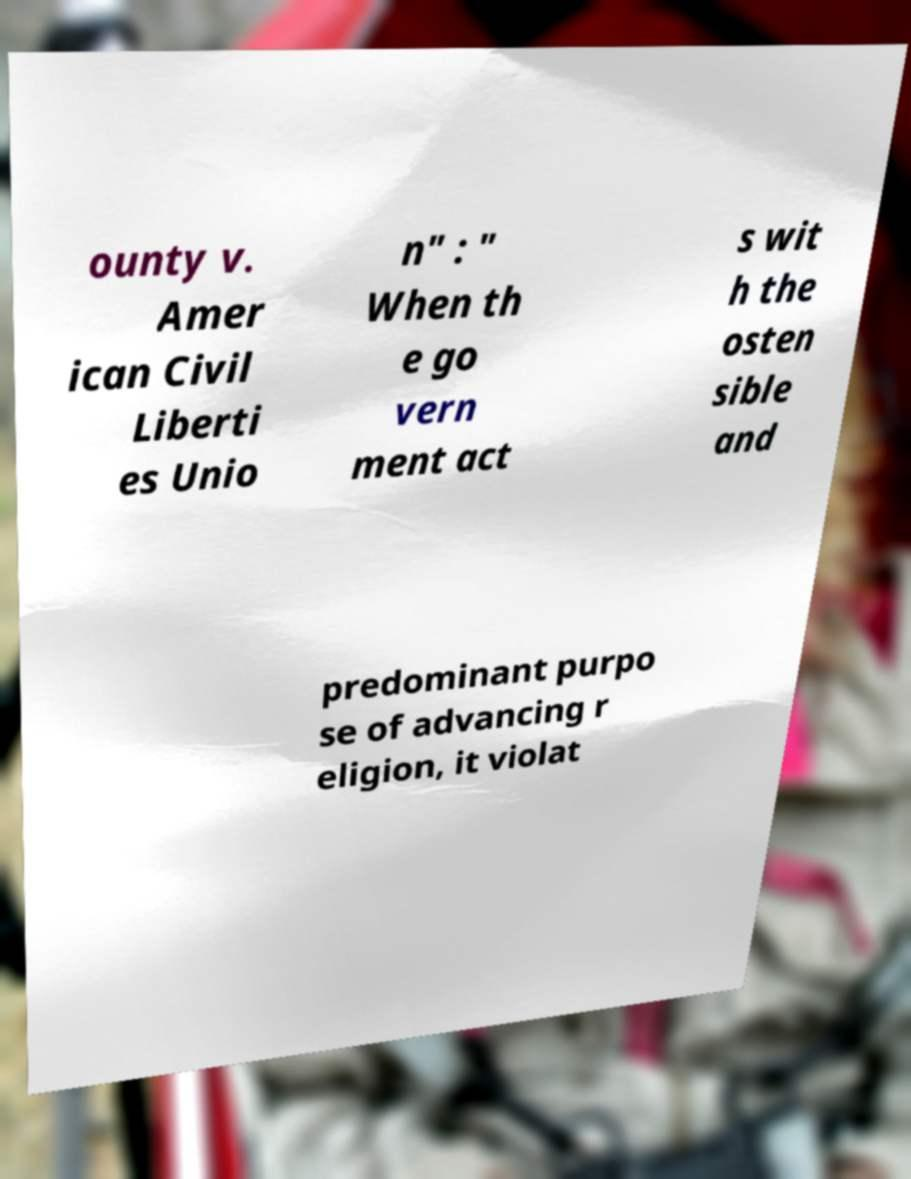Please identify and transcribe the text found in this image. ounty v. Amer ican Civil Liberti es Unio n" : " When th e go vern ment act s wit h the osten sible and predominant purpo se of advancing r eligion, it violat 